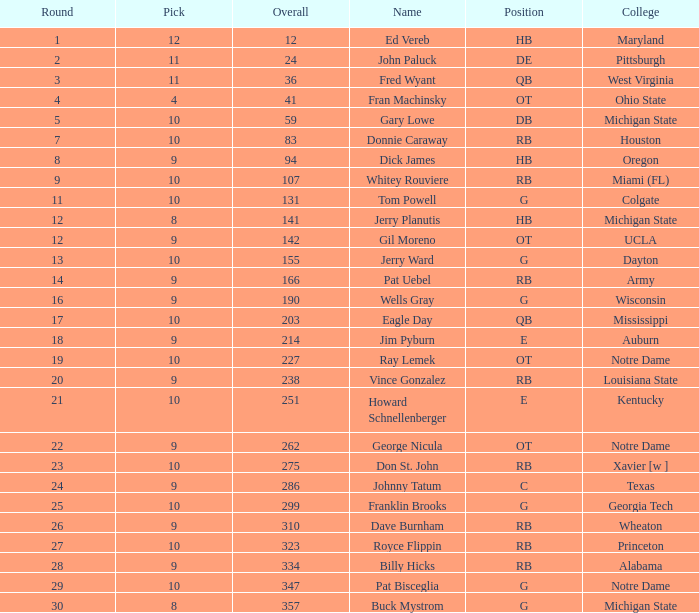How many picks were made after the 9th pick and went to auburn college in total? 0.0. 